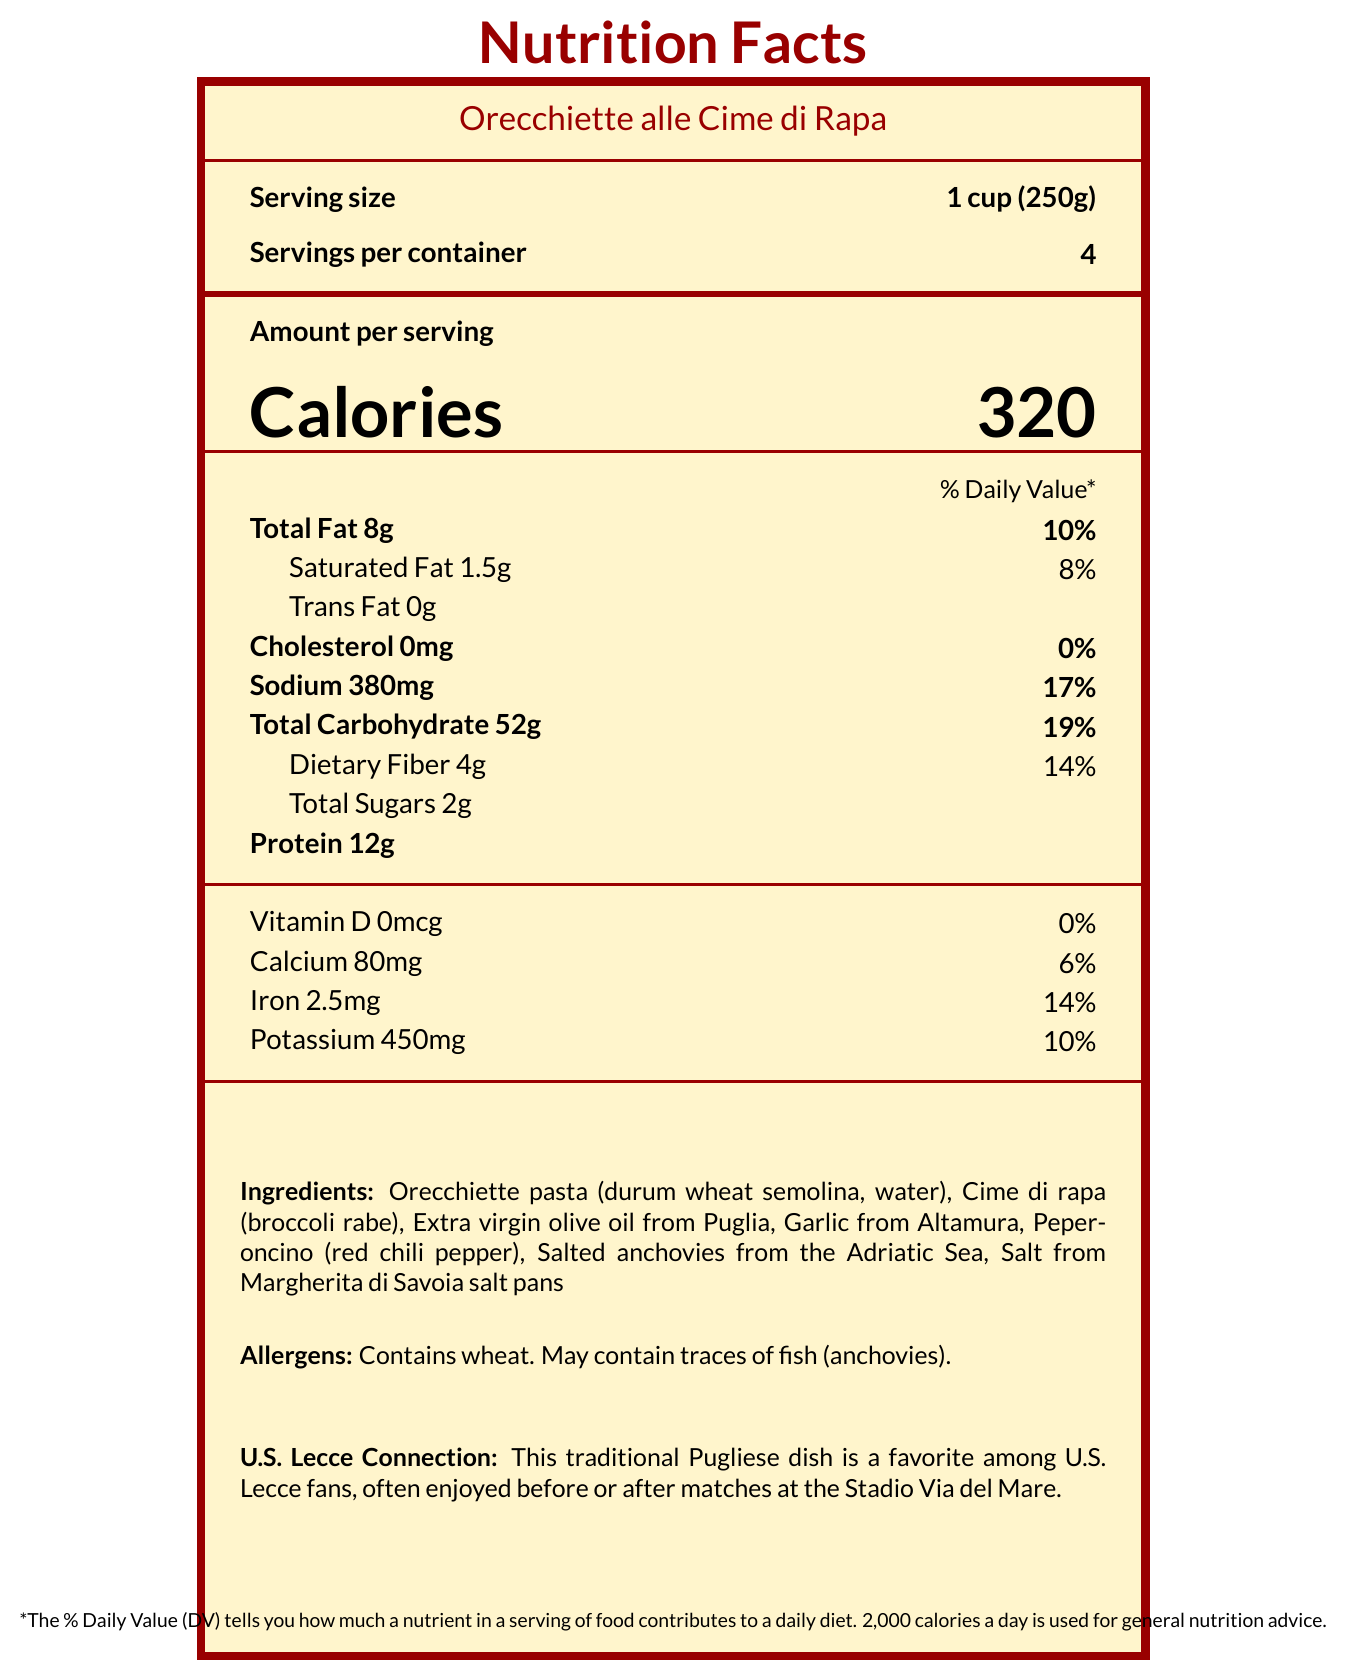What is the serving size for Orecchiette alle Cime di Rapa? The serving size is listed on the document as "1 cup (250g)".
Answer: 1 cup (250g) How many servings are there per container? The document states that there are 4 servings per container.
Answer: 4 How many calories are in one serving of the dish? The number of calories per serving is clearly indicated as 320.
Answer: 320 What is the total fat content per serving? The document lists "Total Fat" as 8g per serving.
Answer: 8g What percentage of the daily value for sodium does one serving provide? The document indicates that the percentage of the daily value for sodium is 17%.
Answer: 17% Which ingredient is known for its intense flavor and aroma? A. Orecchiette pasta B. Cime di rapa C. Garlic from Altamura The document highlights that garlic from Altamura is known for its intense flavor and aroma.
Answer: C. Garlic from Altamura What is the protein content in one serving of Orecchiette alle Cime di Rapa? The document lists the protein content as 12g per serving.
Answer: 12g True or False: The dish contains no trans fat. The document clearly indicates that the trans fat content is 0g.
Answer: True Which local ingredient is harvested from the largest salt pans in Europe? A. Peperoncino B. Salted anchovies C. Salt from Margherita di Savoia The document states that salt from Margherita di Savoia is harvested from the largest salt pans in Europe.
Answer: C. Salt from Margherita di Savoia Does the Nutrition Facts label mention any allergens? The document lists that the dish contains wheat and may contain traces of fish (anchovies).
Answer: Yes Describe the main idea of the document. The document comprehensively lists the nutritional content per serving, the ingredients involved, potential allergens, and emphasizes the local ingredients and the dish's cultural relevance to U.S. Lecce supporters.
Answer: The document provides the nutrition facts for Orecchiette alle Cime di Rapa, a traditional Pugliese pasta dish, including details on serving size, caloric content, and nutritional values. It also highlights the local ingredients used in the recipe, their characteristics, and a special connection to U.S. Lecce fans. How much iron does one serving contain? The document lists the iron content as 2.5mg per serving.
Answer: 2.5mg What is the daily value percentage of dietary fiber per serving? The document states that the daily value percentage for dietary fiber is 14%.
Answer: 14% What is the main ingredient in the pasta used in the dish? Orecchiette pasta is made from durum wheat semolina and water.
Answer: Durum wheat semolina Which ingredient comes from Puglia's ancient olive groves? The document highlights that the extra virgin olive oil is produced from olives grown in Puglia's ancient olive groves.
Answer: Extra virgin olive oil What is the u_s_lecce_connection mentioned in the document? The document states that this traditional Pugliese dish is popular with U.S. Lecce fans and is often enjoyed in relation to matches.
Answer: The dish is a favorite among U.S. Lecce fans, often enjoyed before or after matches at the Stadio Via del Mare. What is the main source of dietary fiber in the dish? Broccoli rabe, known locally as cime di rapa, is one of the ingredients contributing to the dietary fiber content.
Answer: Cime di rapa (broccoli rabe) Which of the following amounts are incorrect in the label? A. Total Sugars 2g B. Protein 12g C. Potassium 600mg The document states the correct potassium content is 450mg, not 600mg.
Answer: C. Potassium 600mg Which ingredient might cause an allergic reaction due to fish? The document notes that the dish may contain traces of fish (anchovies) and lists it under allergens.
Answer: Salted anchovies What is the percentage of daily value for calcium? The document lists the calcium daily value percentage as 6%.
Answer: 6% What is the daily value percentage for the total carbohydrate content? The document states that the daily value percentage for total carbohydrates is 19%.
Answer: 19% What kind of nutrient information is missing for Vitamin D? The document indicates Vitamin D as 0mcg and 0% daily value, essentially showing no Vitamin D content.
Answer: Daily value percentage and amount Is there a special connection of the dish to any sports team? The document mentions a connection to U.S. Lecce, noting that the dish is a favorite among fans.
Answer: Yes Where exactly are the salted anchovies sourced from? The document states that the salted anchovies come from the Adriatic Sea.
Answer: The Adriatic Sea Can the exact recipe for the dish be determined from the document? The document lists the ingredients but do not provide the full recipe including preparation instructions.
Answer: No 